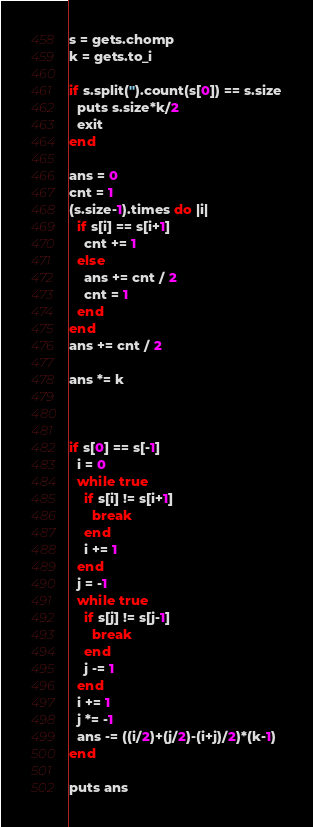Convert code to text. <code><loc_0><loc_0><loc_500><loc_500><_Ruby_>s = gets.chomp
k = gets.to_i

if s.split('').count(s[0]) == s.size
  puts s.size*k/2
  exit
end

ans = 0
cnt = 1
(s.size-1).times do |i|
  if s[i] == s[i+1]
    cnt += 1
  else
    ans += cnt / 2
    cnt = 1
  end
end
ans += cnt / 2

ans *= k



if s[0] == s[-1]
  i = 0
  while true
    if s[i] != s[i+1]
      break
    end
    i += 1
  end
  j = -1
  while true
    if s[j] != s[j-1]
      break
    end
    j -= 1
  end
  i += 1
  j *= -1
  ans -= ((i/2)+(j/2)-(i+j)/2)*(k-1)
end

puts ans</code> 